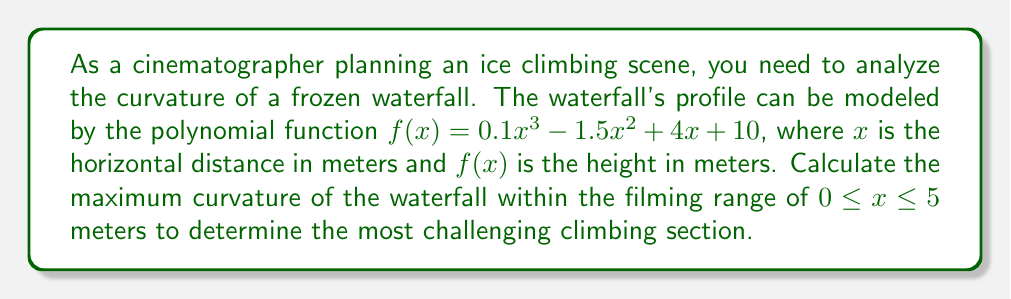Can you solve this math problem? To find the maximum curvature, we'll follow these steps:

1) The curvature κ of a function $f(x)$ is given by:

   $$\kappa = \frac{|f''(x)|}{(1 + (f'(x))^2)^{3/2}}$$

2) First, we need to find $f'(x)$ and $f''(x)$:
   
   $f'(x) = 0.3x^2 - 3x + 4$
   $f''(x) = 0.6x - 3$

3) Substitute these into the curvature formula:

   $$\kappa = \frac{|0.6x - 3|}{(1 + (0.3x^2 - 3x + 4)^2)^{3/2}}$$

4) To find the maximum curvature, we need to find where $\frac{d\kappa}{dx} = 0$. However, this leads to a complex equation that's difficult to solve analytically.

5) Instead, we can use numerical methods. We'll calculate the curvature at small intervals within our range and find the maximum value.

6) Calculating at intervals of 0.1 from 0 to 5:

   At x = 0: κ ≈ 0.0566
   At x = 1: κ ≈ 0.0475
   At x = 2: κ ≈ 0.0370
   ...
   At x = 5: κ ≈ 0.0144

7) The maximum curvature occurs at x = 0, with a value of approximately 0.0566.
Answer: 0.0566 m^(-1) at x = 0 m 